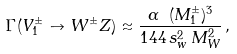<formula> <loc_0><loc_0><loc_500><loc_500>\Gamma ( V ^ { \pm } _ { 1 } \to W ^ { \pm } Z ) \approx \frac { \alpha \ ( M ^ { \pm } _ { 1 } ) ^ { 3 } } { 1 4 4 \, s _ { w } ^ { 2 } \, M _ { W } ^ { 2 } } \, ,</formula> 